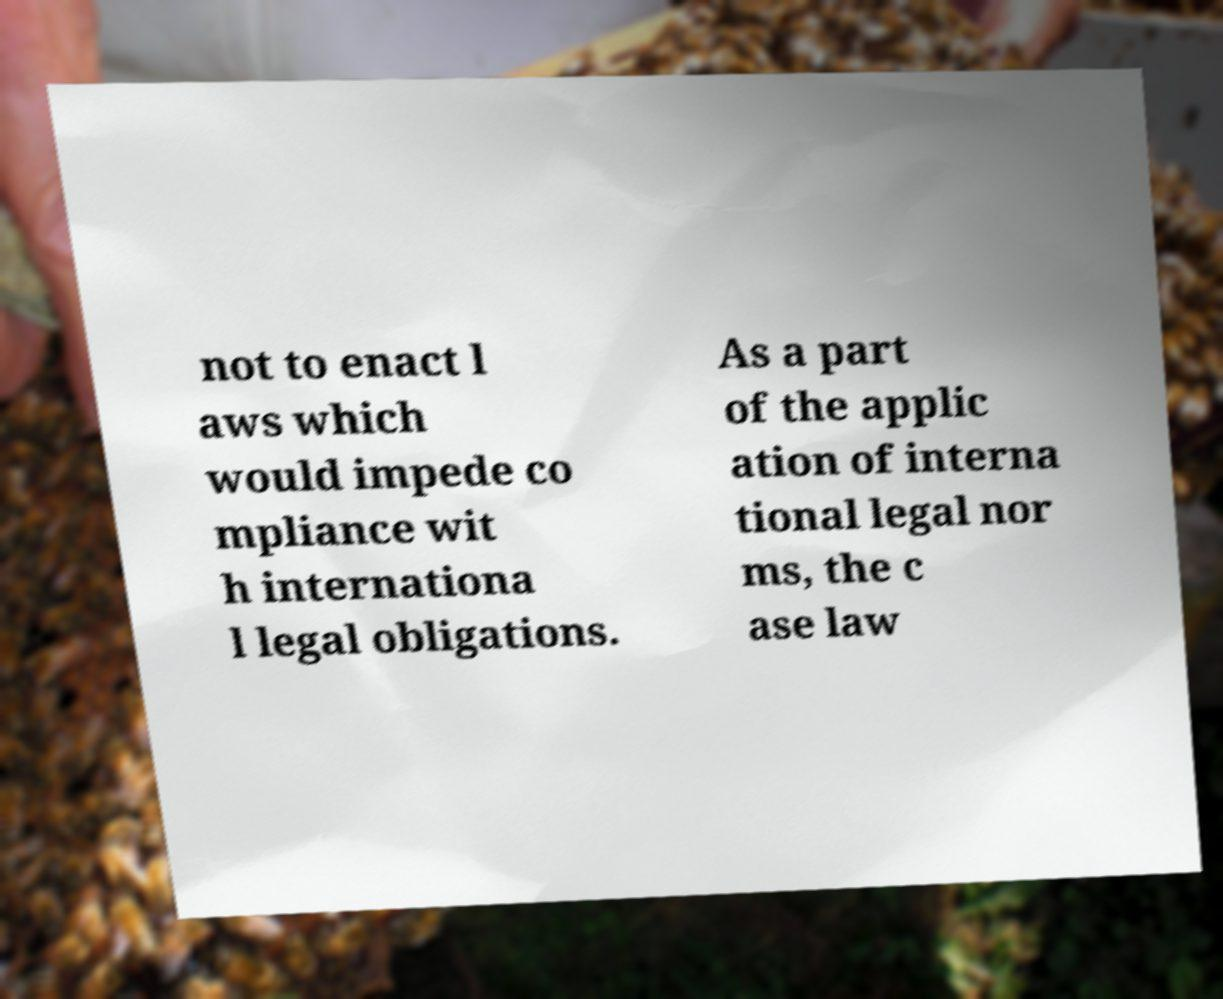Can you read and provide the text displayed in the image?This photo seems to have some interesting text. Can you extract and type it out for me? not to enact l aws which would impede co mpliance wit h internationa l legal obligations. As a part of the applic ation of interna tional legal nor ms, the c ase law 